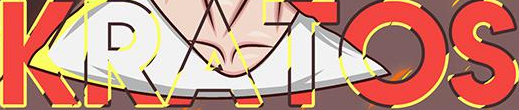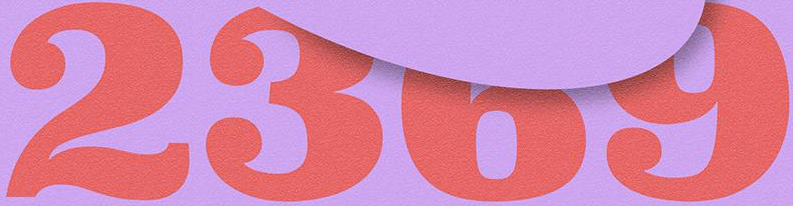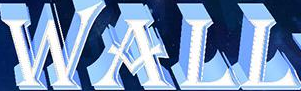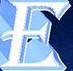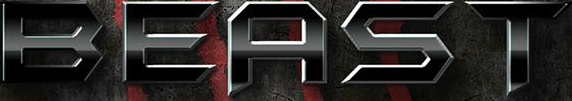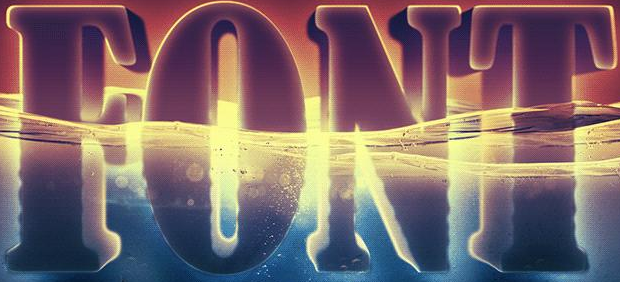What text is displayed in these images sequentially, separated by a semicolon? KRATOS; 2369; WALL; E; BEAST; FONT 